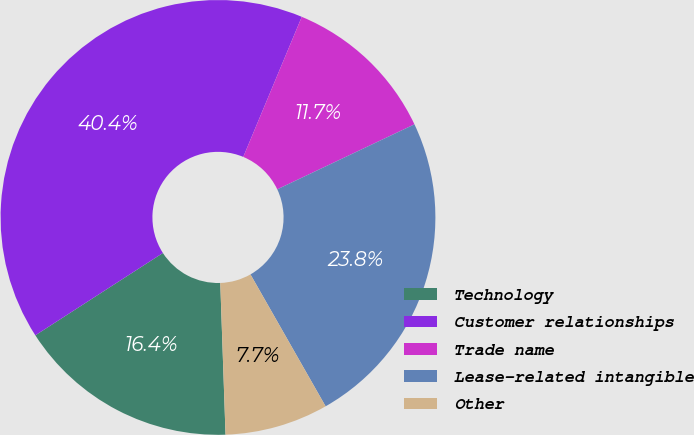<chart> <loc_0><loc_0><loc_500><loc_500><pie_chart><fcel>Technology<fcel>Customer relationships<fcel>Trade name<fcel>Lease-related intangible<fcel>Other<nl><fcel>16.43%<fcel>40.42%<fcel>11.66%<fcel>23.8%<fcel>7.69%<nl></chart> 